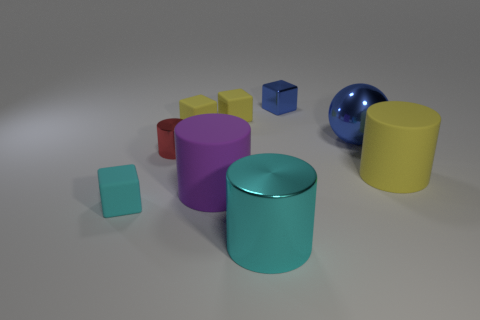Subtract all purple blocks. Subtract all cyan cylinders. How many blocks are left? 4 Subtract all spheres. How many objects are left? 8 Subtract all red objects. Subtract all blue things. How many objects are left? 6 Add 3 yellow cylinders. How many yellow cylinders are left? 4 Add 1 small blue metallic cylinders. How many small blue metallic cylinders exist? 1 Subtract 0 red cubes. How many objects are left? 9 